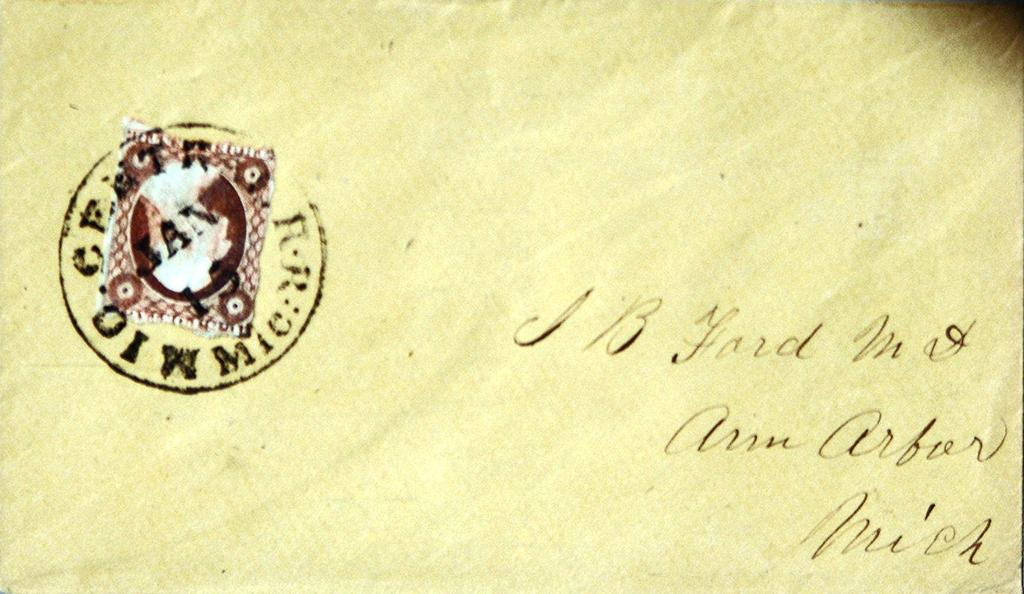<image>
Give a short and clear explanation of the subsequent image. yellow envelope addressed to J B ford in Ann Arbor Michigan 